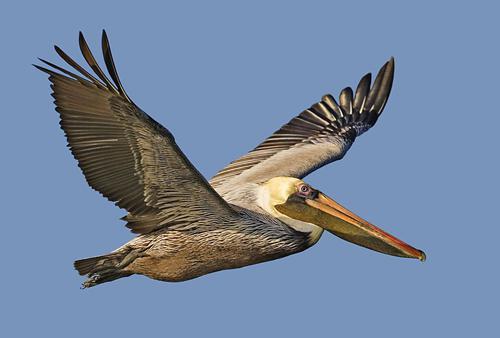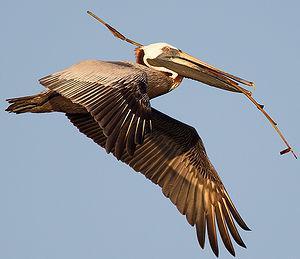The first image is the image on the left, the second image is the image on the right. Considering the images on both sides, is "A bird is perched on a rock." valid? Answer yes or no. No. The first image is the image on the left, the second image is the image on the right. Evaluate the accuracy of this statement regarding the images: "Two long-beaked birds are shown in flight, both with wings outspread, but one with them pointed downward, and the other with them pointed upward.". Is it true? Answer yes or no. Yes. 